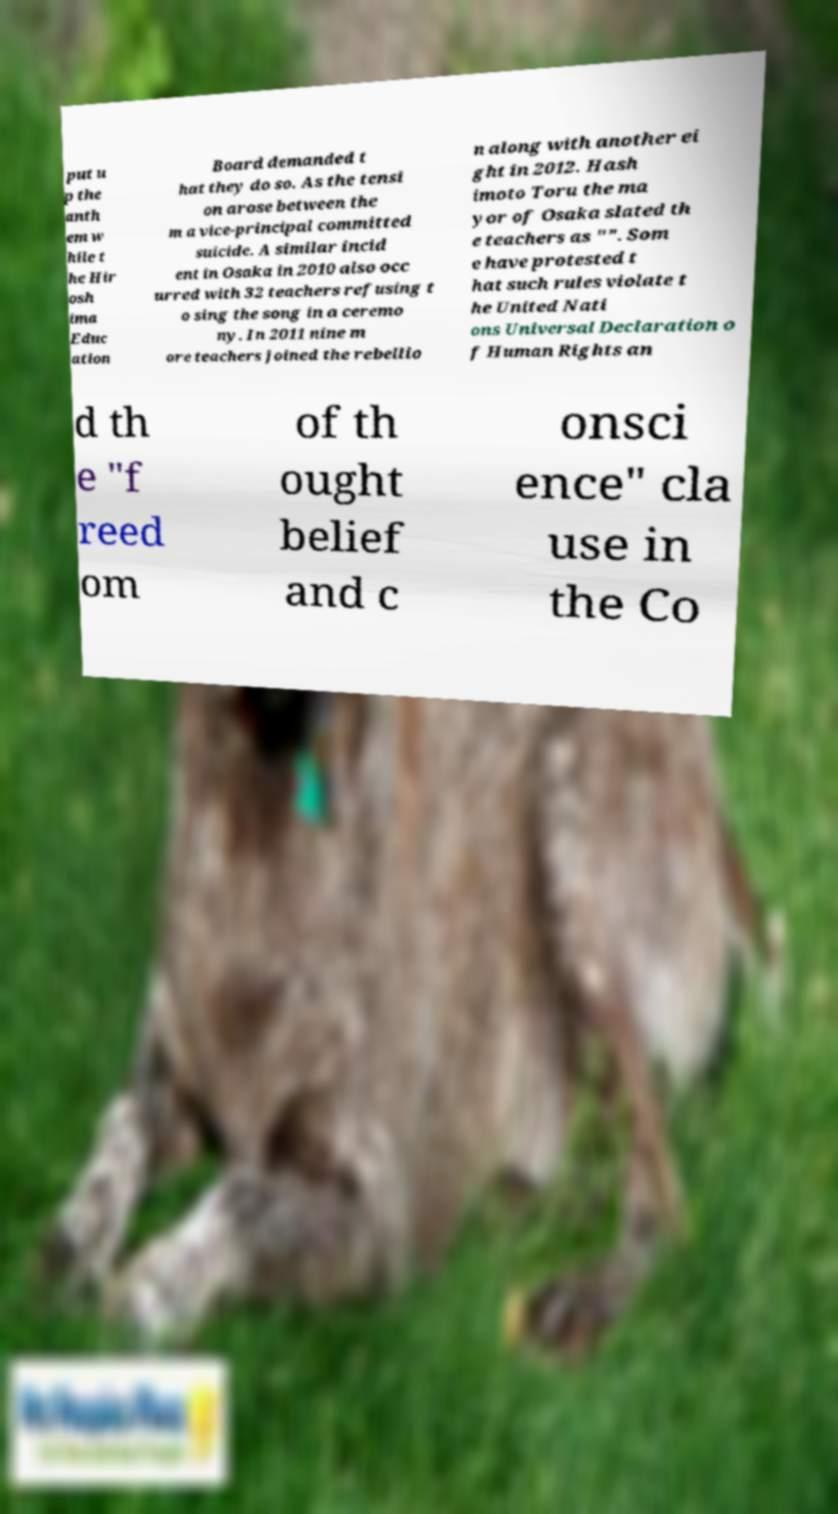Please identify and transcribe the text found in this image. put u p the anth em w hile t he Hir osh ima Educ ation Board demanded t hat they do so. As the tensi on arose between the m a vice-principal committed suicide. A similar incid ent in Osaka in 2010 also occ urred with 32 teachers refusing t o sing the song in a ceremo ny. In 2011 nine m ore teachers joined the rebellio n along with another ei ght in 2012. Hash imoto Toru the ma yor of Osaka slated th e teachers as "". Som e have protested t hat such rules violate t he United Nati ons Universal Declaration o f Human Rights an d th e "f reed om of th ought belief and c onsci ence" cla use in the Co 